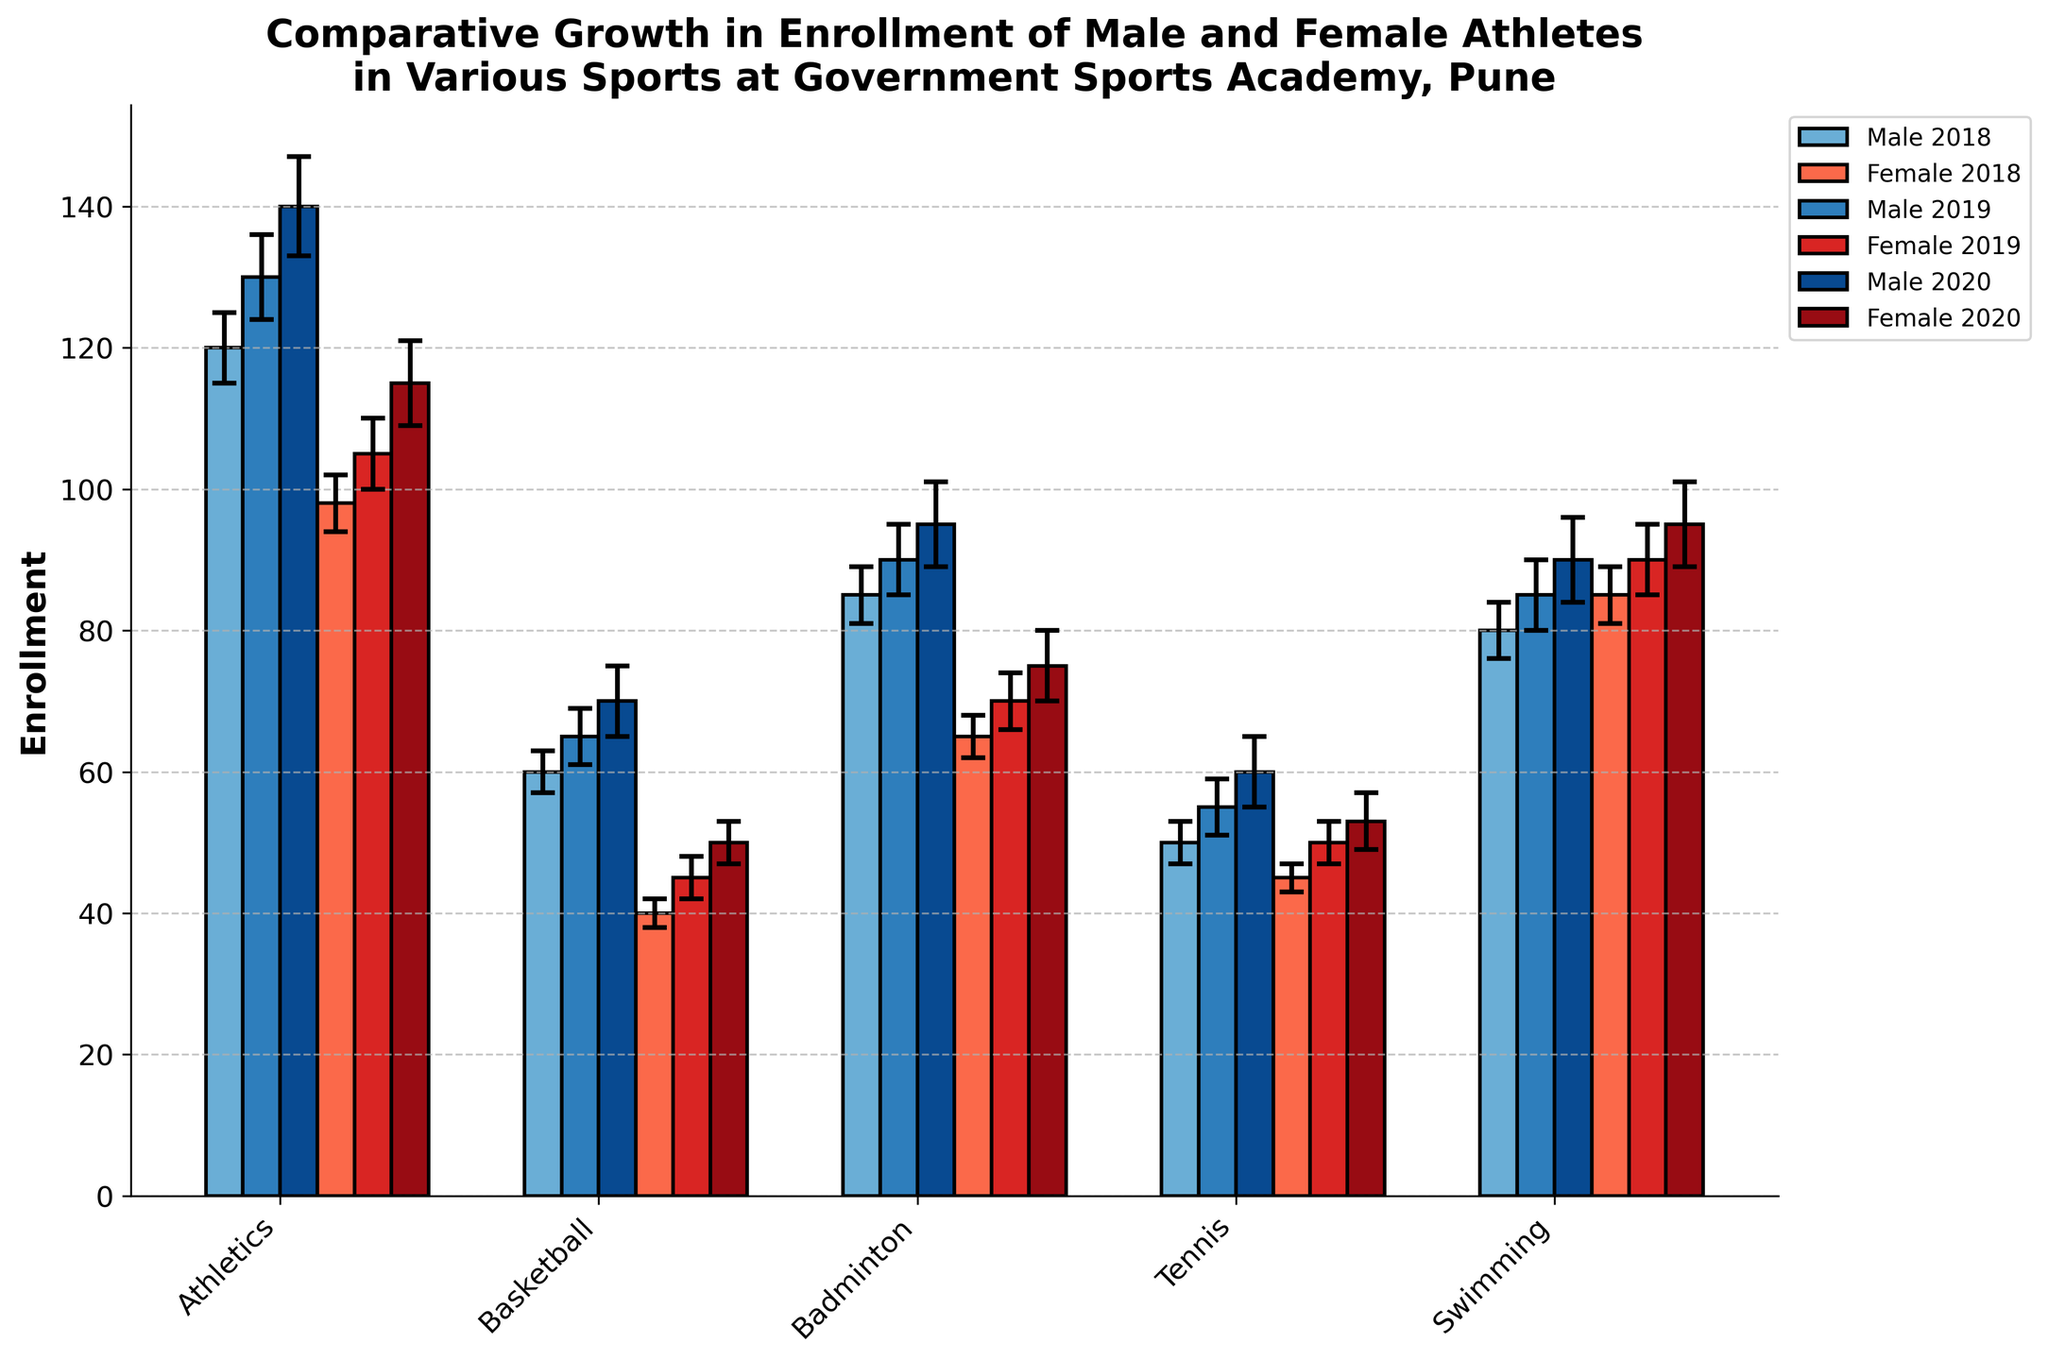What's the title of the plot? The title can be found at the top of the plot, which usually gives an overview of the information displayed.
Answer: Comparative Growth in Enrollment of Male and Female Athletes in Various Sports at Government Sports Academy, Pune How many sports are compared in the plot? The number of sports compared can be identified by counting the categories on the x-axis.
Answer: 5 Which sport had the highest enrollment for female athletes in 2020? Look for the tallest bar among the female categories in 2020.
Answer: Swimming Which year had the lowest male enrollment in Basketball? Compare the heights of the male bars for different years in Basketball.
Answer: 2018 Did male or female athlete enrollments generally increase or decrease from 2018 to 2020? Check the direction of change for the heights of the bars across years for both male and female enrollments.
Answer: Increase How does the male enrollment in Athletics compare to female enrollment in Athletics for 2020? Identify the heights of both male and female bars for Athletics in 2020 and compare them.
Answer: Male enrollment is higher What's the average male enrollment in Athletics across all three years shown? Sum up the male enrollments in Athletics for 2018, 2019, and 2020, then divide by 3. \( (120 + 130 + 140) / 3 = 130 \)
Answer: 130 What does the error bar in each bar signify? The error bars represent the standard error in the enrollment data, indicating the uncertainty or variability in the measurements.
Answer: Standard error Between male and female swimmers in 2018, whose enrollment standard error was higher? Compare the lengths of the error bars for male and female swimmers in 2018.
Answer: They are equal 